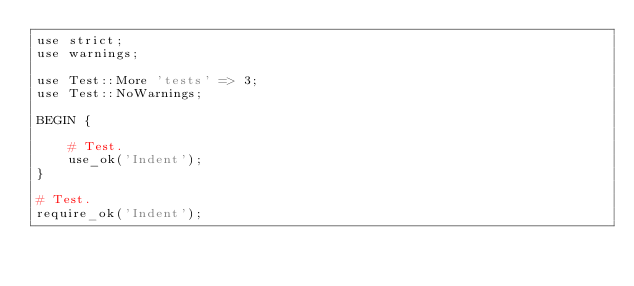<code> <loc_0><loc_0><loc_500><loc_500><_Perl_>use strict;
use warnings;

use Test::More 'tests' => 3;
use Test::NoWarnings;

BEGIN {

	# Test.
	use_ok('Indent');
}

# Test.
require_ok('Indent');
</code> 